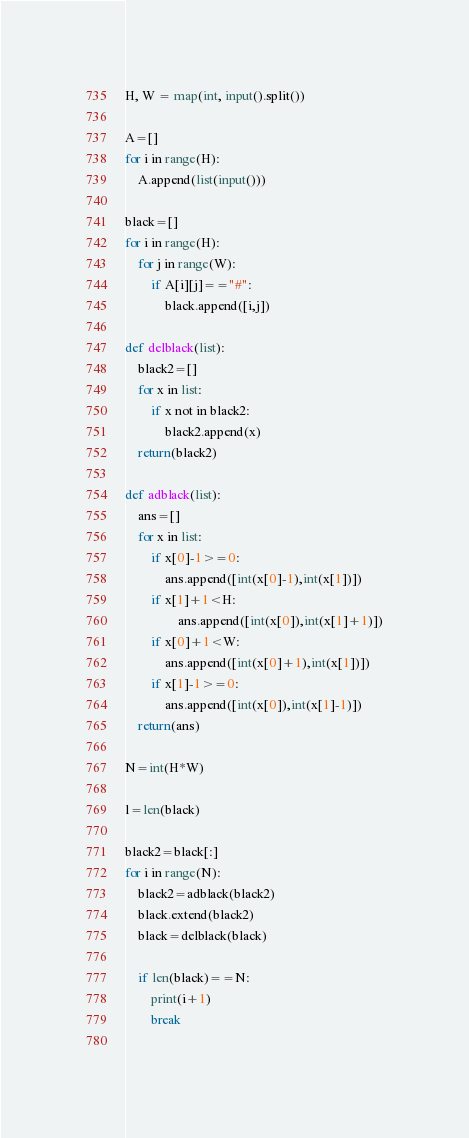Convert code to text. <code><loc_0><loc_0><loc_500><loc_500><_Python_>H, W = map(int, input().split())

A=[]
for i in range(H):
    A.append(list(input()))
    
black=[]
for i in range(H):
    for j in range(W):
        if A[i][j]=="#":
            black.append([i,j])

def delblack(list):
    black2=[]
    for x in list:
        if x not in black2:
            black2.append(x)
    return(black2)

def adblack(list):
    ans=[]
    for x in list:
        if x[0]-1>=0:
            ans.append([int(x[0]-1),int(x[1])])
        if x[1]+1<H:
                ans.append([int(x[0]),int(x[1]+1)])
        if x[0]+1<W:
            ans.append([int(x[0]+1),int(x[1])])
        if x[1]-1>=0:
            ans.append([int(x[0]),int(x[1]-1)])
    return(ans)

N=int(H*W)

l=len(black)

black2=black[:]
for i in range(N):
    black2=adblack(black2)
    black.extend(black2)
    black=delblack(black)
    
    if len(black)==N:
        print(i+1)
        break
        </code> 